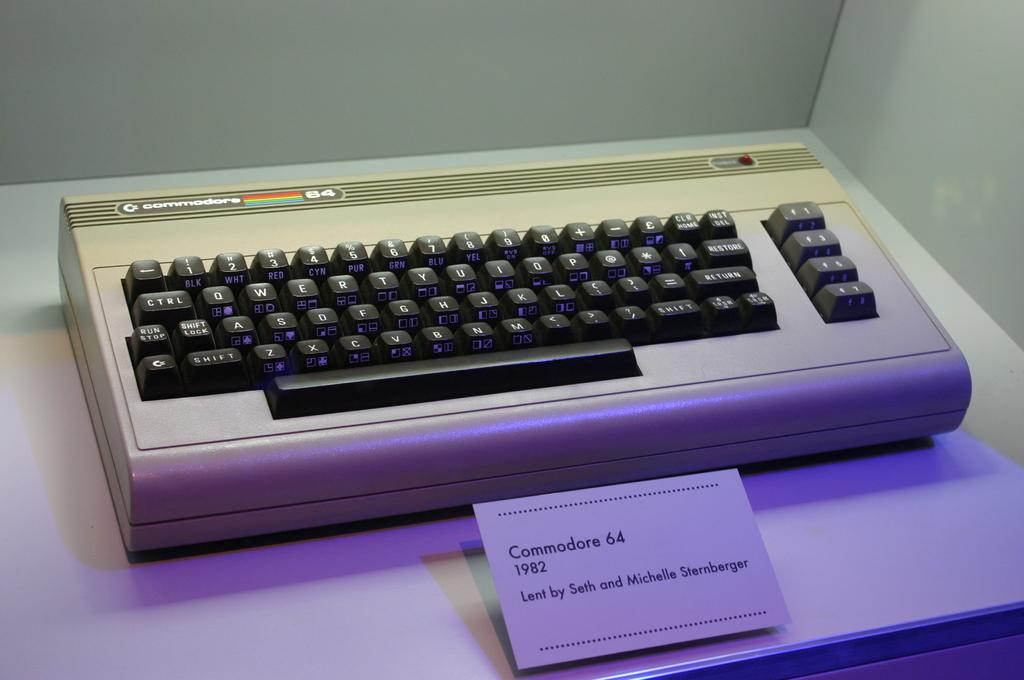<image>
Relay a brief, clear account of the picture shown. A keyboard on display with a note card reading " Commodore 64 1982". 